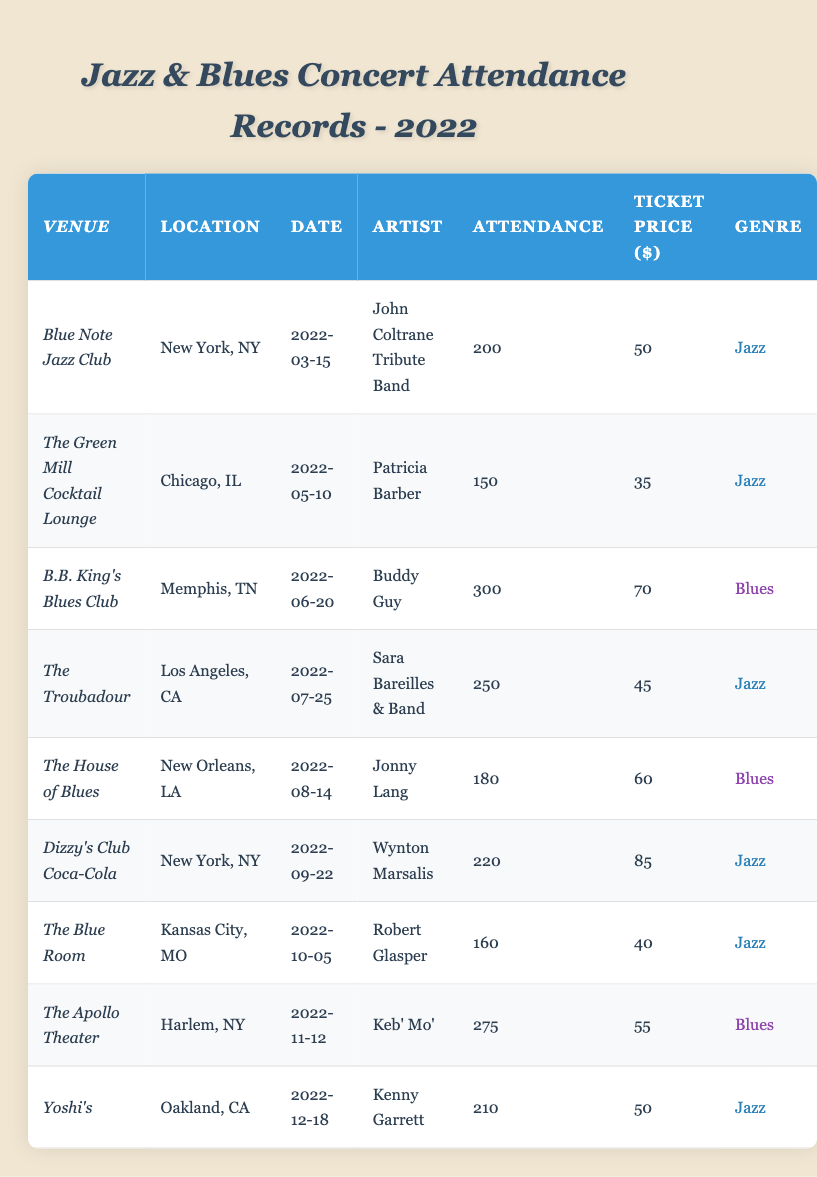What is the total attendance at B.B. King's Blues Club? The attendance figure for B.B. King's Blues Club is directly listed in the table as 300.
Answer: 300 What is the ticket price for the concert by Wynton Marsalis at Dizzy's Club Coca-Cola? The ticket price is mentioned in the table beside Wynton Marsalis's concert and is listed as 85.
Answer: 85 Which artist performed at The Apollo Theater and what was the genre of the concert? The Apollo Theater's entry shows that Keb' Mo' performed there, and the genre is classified as Blues.
Answer: Keb' Mo', Blues How many concerts were held in New York? There are 3 entries for concerts held in New York: Blue Note Jazz Club, Dizzy's Club Coca-Cola, and The Apollo Theater.
Answer: 3 What is the average ticket price for all the concerts? The ticket prices are: 50, 35, 70, 45, 60, 85, 40, 55, and 50. Summing these gives 50 + 35 + 70 + 45 + 60 + 85 + 40 + 55 + 50 = 485. There are 9 concerts, so the average is 485 / 9 ≈ 53.89.
Answer: 53.89 Is the attendance at The Troubadour greater than that at The House of Blues? The Troubadour's attendance is 250 while The House of Blues has 180. Since 250 is greater than 180, the statement is true.
Answer: Yes What was the attendance at the Jazz concerts compared to the Blues concerts? Total attendance for Jazz concerts (200 + 150 + 250 + 220 + 160 + 210) = 1190. For Blues concerts (300 + 180 + 275) = 755. Comparing 1190 and 755 shows Jazz concerts had higher attendance.
Answer: Jazz concerts had higher attendance Which location had the concert with the highest attendance and what was it? The highest attendance recorded is 300 at B.B. King's Blues Club in Memphis, TN.
Answer: Memphis, TN; 300 What is the total revenue generated from ticket sales for the concert at Yoshi's? The ticket price for the concert at Yoshi's is 50 and the attendance is 210. Thus, total revenue is 50 * 210 = 10500.
Answer: 10500 If you combine the attendance of the concerts in Chicago and New Orleans, what is the total? Chicago's concert attendance is 150, and New Orleans' is 180. Adding these gives 150 + 180 = 330.
Answer: 330 